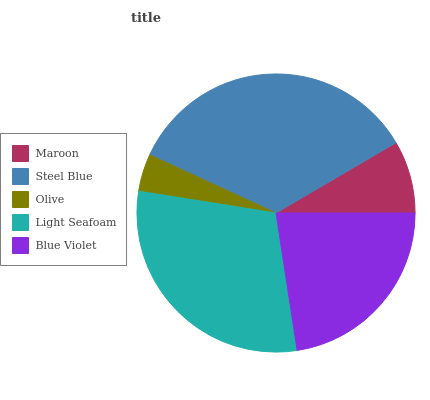Is Olive the minimum?
Answer yes or no. Yes. Is Steel Blue the maximum?
Answer yes or no. Yes. Is Steel Blue the minimum?
Answer yes or no. No. Is Olive the maximum?
Answer yes or no. No. Is Steel Blue greater than Olive?
Answer yes or no. Yes. Is Olive less than Steel Blue?
Answer yes or no. Yes. Is Olive greater than Steel Blue?
Answer yes or no. No. Is Steel Blue less than Olive?
Answer yes or no. No. Is Blue Violet the high median?
Answer yes or no. Yes. Is Blue Violet the low median?
Answer yes or no. Yes. Is Maroon the high median?
Answer yes or no. No. Is Steel Blue the low median?
Answer yes or no. No. 